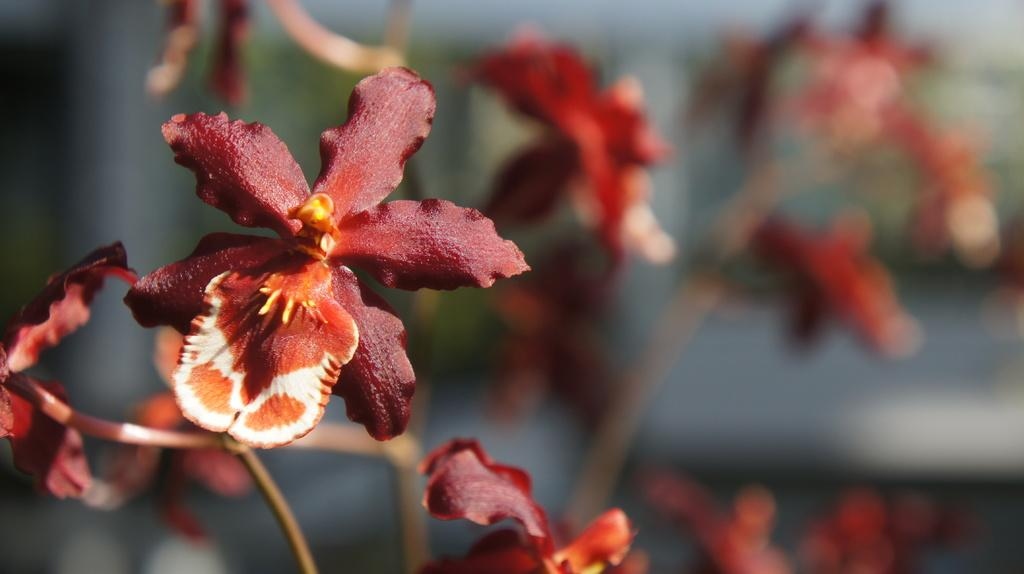What type of flora is present in the image? There are flowers in the image. What color are the flowers? The flowers are brown in color, specifically pale brown. Are there any other colors present in the flowers? Yes, the flowers are also white in color. How is the background of the image depicted? The background of the image is blurred. What type of lace is used to decorate the flowers in the image? There is no lace present in the image; it features flowers with specific colors and a blurred background. What is your opinion on the arrangement of the flowers in the image? As an AI, I do not have personal opinions. However, the image shows flowers with specific colors and a blurred background. 